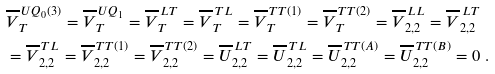Convert formula to latex. <formula><loc_0><loc_0><loc_500><loc_500>& \overline { V } _ { T } ^ { \, U Q _ { 0 } ( 3 ) } = \overline { V } _ { T } ^ { \, U Q _ { 1 } } = \overline { V } _ { T } ^ { \, L T } = \overline { V } _ { T } ^ { \, T L } = \overline { V } _ { T } ^ { \, T T ( 1 ) } = \overline { V } _ { T } ^ { \, T T ( 2 ) } = \overline { V } _ { 2 , 2 } ^ { \, L L } = \overline { V } _ { 2 , 2 } ^ { \, L T } \\ & = \overline { V } _ { 2 , 2 } ^ { \, T L } = \overline { V } _ { 2 , 2 } ^ { \, T T ( 1 ) } = \overline { V } _ { 2 , 2 } ^ { \, T T ( 2 ) } = \overline { U } _ { 2 , 2 } ^ { \, L T } = \overline { U } _ { 2 , 2 } ^ { \, T L } = \overline { U } _ { 2 , 2 } ^ { \, T T ( A ) } = \overline { U } _ { 2 , 2 } ^ { \, T T ( B ) } = 0 \ .</formula> 